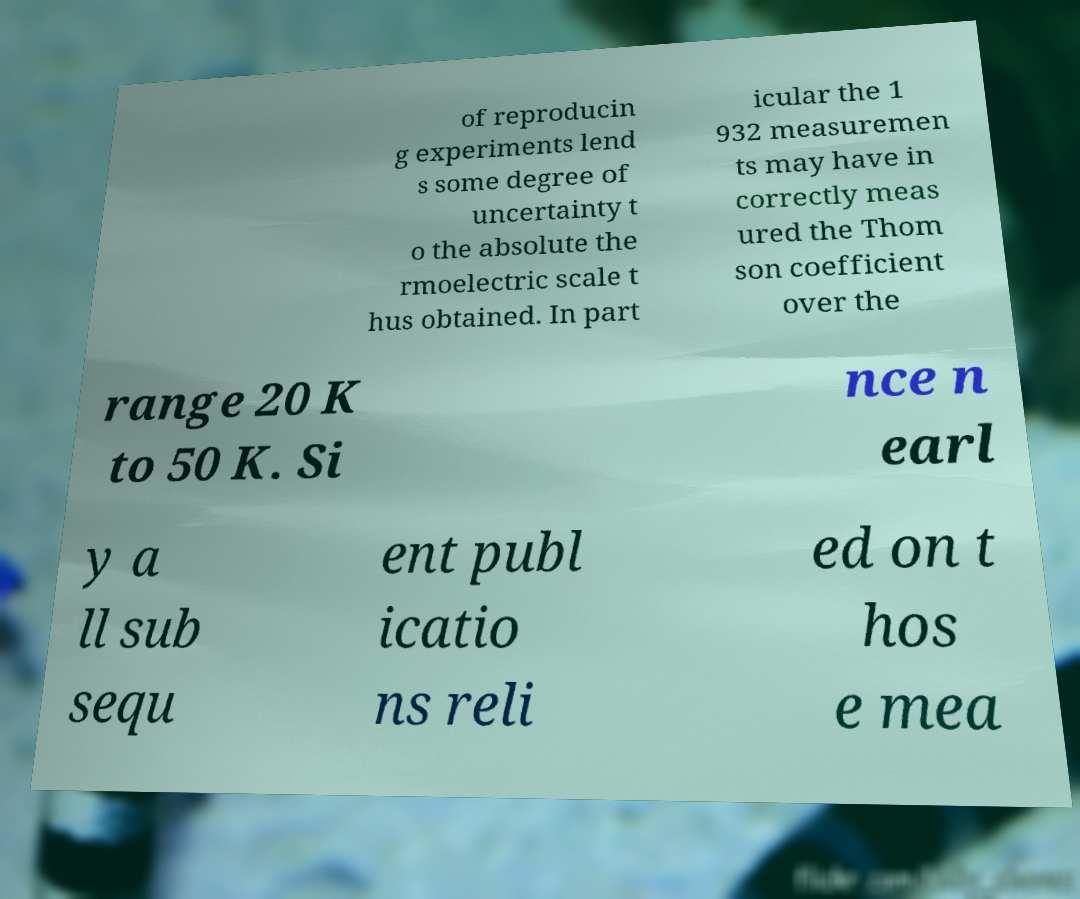For documentation purposes, I need the text within this image transcribed. Could you provide that? of reproducin g experiments lend s some degree of uncertainty t o the absolute the rmoelectric scale t hus obtained. In part icular the 1 932 measuremen ts may have in correctly meas ured the Thom son coefficient over the range 20 K to 50 K. Si nce n earl y a ll sub sequ ent publ icatio ns reli ed on t hos e mea 